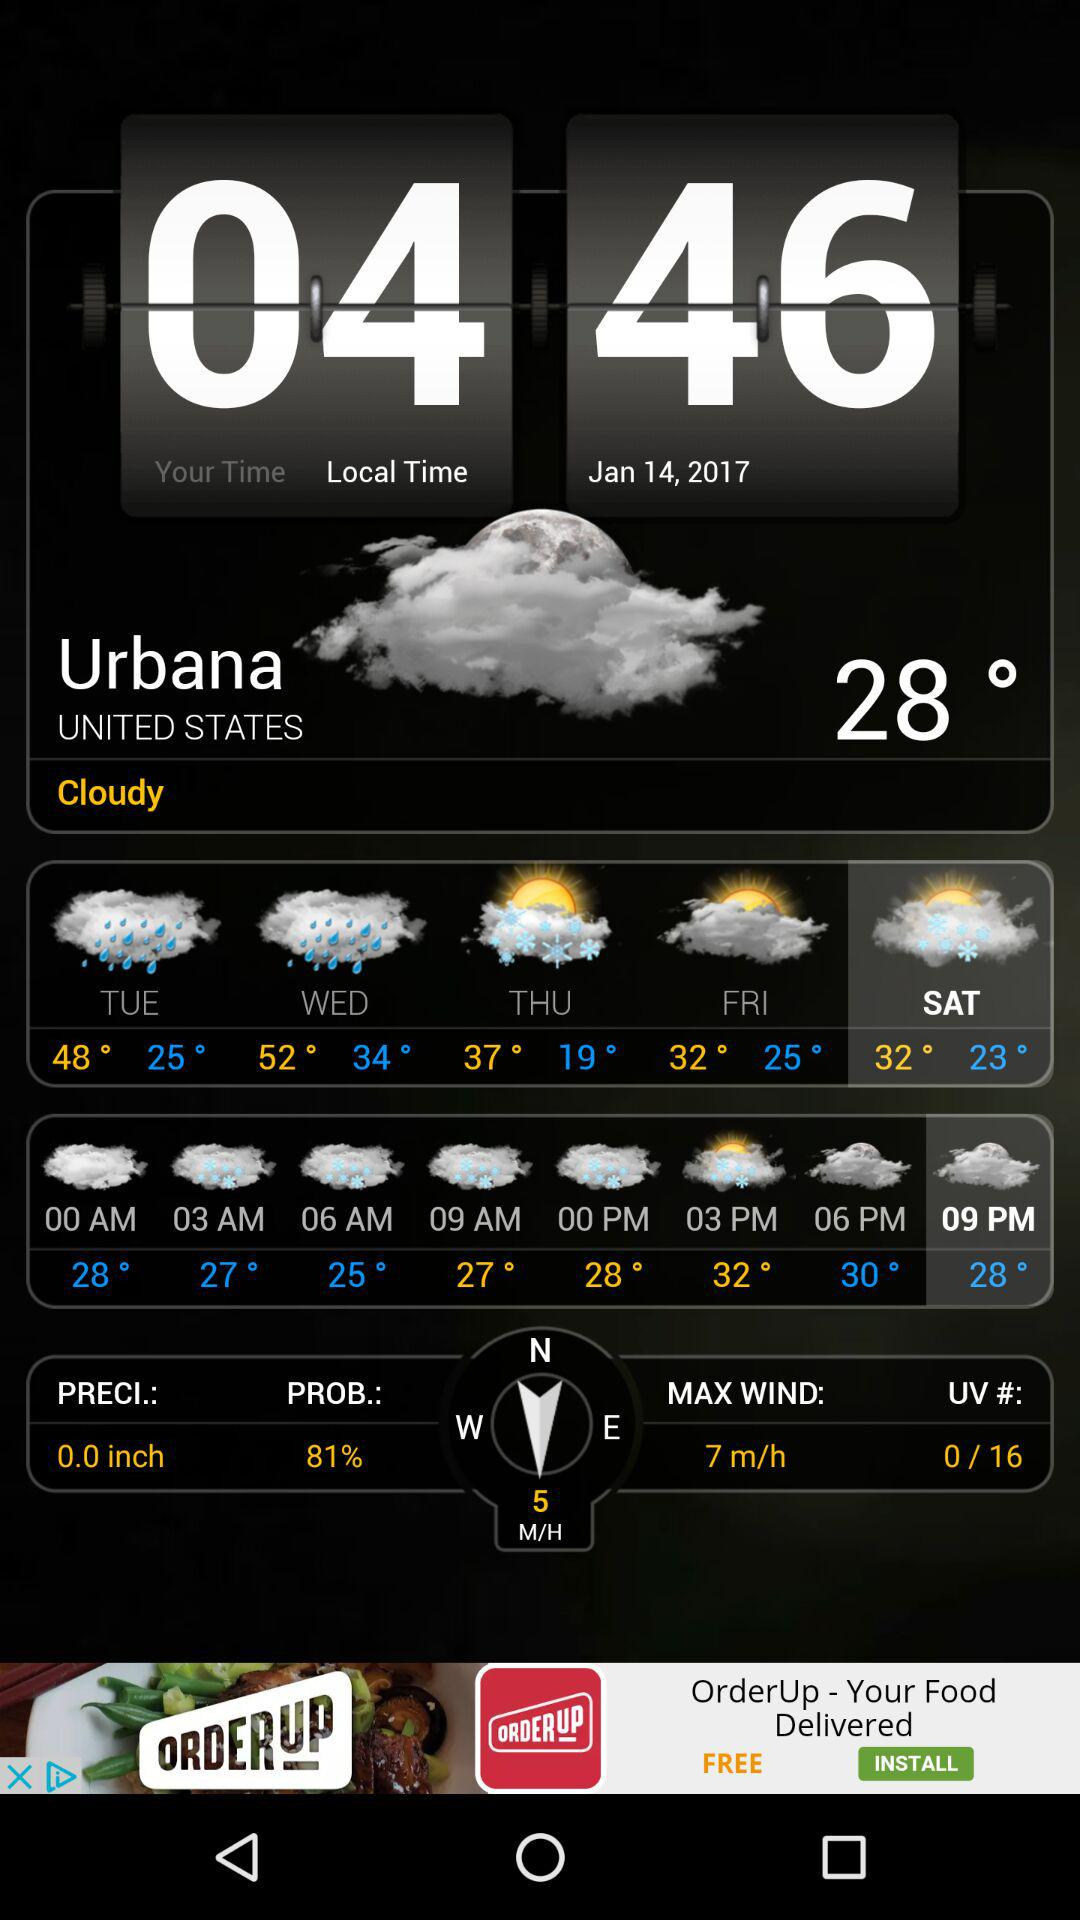What is the maximum wind speed?
Answer the question using a single word or phrase. 7 m/h 